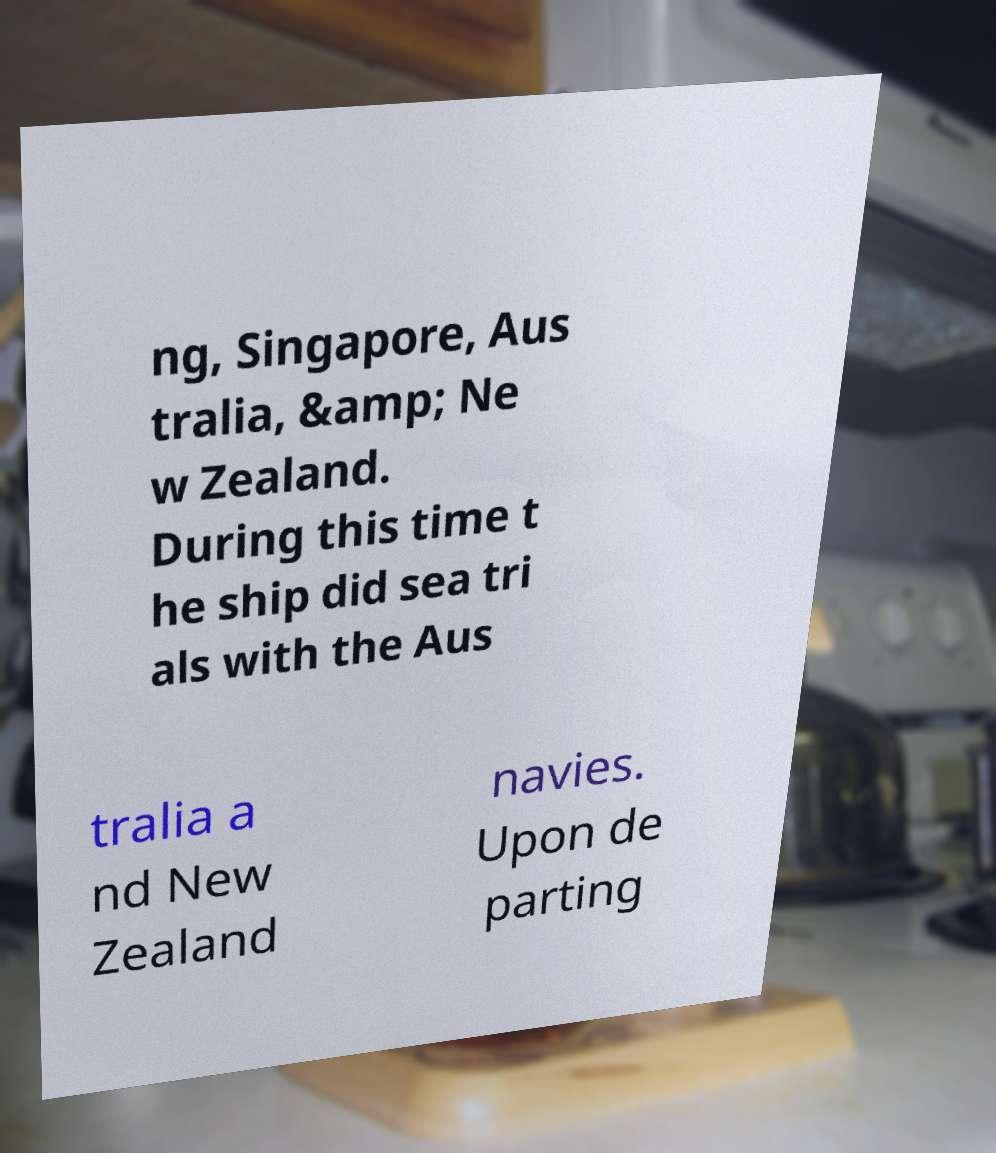Could you extract and type out the text from this image? ng, Singapore, Aus tralia, &amp; Ne w Zealand. During this time t he ship did sea tri als with the Aus tralia a nd New Zealand navies. Upon de parting 